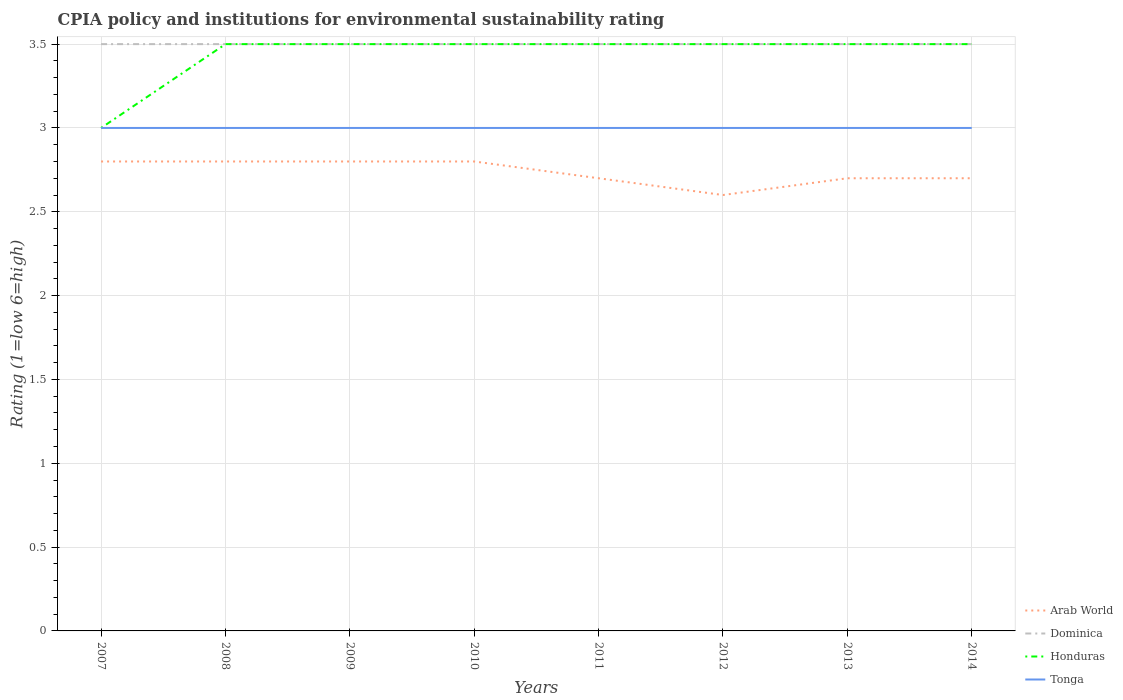How many different coloured lines are there?
Make the answer very short. 4. Does the line corresponding to Dominica intersect with the line corresponding to Tonga?
Keep it short and to the point. No. Is the number of lines equal to the number of legend labels?
Your answer should be very brief. Yes. Across all years, what is the maximum CPIA rating in Arab World?
Ensure brevity in your answer.  2.6. In which year was the CPIA rating in Arab World maximum?
Provide a succinct answer. 2012. What is the total CPIA rating in Arab World in the graph?
Offer a terse response. 0. What is the difference between the highest and the second highest CPIA rating in Tonga?
Offer a terse response. 0. What is the difference between the highest and the lowest CPIA rating in Arab World?
Offer a terse response. 4. How many years are there in the graph?
Ensure brevity in your answer.  8. What is the difference between two consecutive major ticks on the Y-axis?
Your answer should be compact. 0.5. Are the values on the major ticks of Y-axis written in scientific E-notation?
Make the answer very short. No. Does the graph contain any zero values?
Offer a terse response. No. Where does the legend appear in the graph?
Keep it short and to the point. Bottom right. How many legend labels are there?
Ensure brevity in your answer.  4. What is the title of the graph?
Keep it short and to the point. CPIA policy and institutions for environmental sustainability rating. What is the Rating (1=low 6=high) in Honduras in 2007?
Ensure brevity in your answer.  3. What is the Rating (1=low 6=high) of Arab World in 2008?
Offer a very short reply. 2.8. What is the Rating (1=low 6=high) of Dominica in 2008?
Ensure brevity in your answer.  3.5. What is the Rating (1=low 6=high) of Honduras in 2008?
Provide a short and direct response. 3.5. What is the Rating (1=low 6=high) of Dominica in 2009?
Make the answer very short. 3.5. What is the Rating (1=low 6=high) of Honduras in 2009?
Provide a succinct answer. 3.5. What is the Rating (1=low 6=high) of Dominica in 2010?
Provide a succinct answer. 3.5. What is the Rating (1=low 6=high) of Honduras in 2010?
Make the answer very short. 3.5. What is the Rating (1=low 6=high) of Tonga in 2010?
Your answer should be compact. 3. What is the Rating (1=low 6=high) of Tonga in 2011?
Ensure brevity in your answer.  3. What is the Rating (1=low 6=high) in Arab World in 2012?
Your response must be concise. 2.6. What is the Rating (1=low 6=high) in Dominica in 2012?
Your answer should be very brief. 3.5. What is the Rating (1=low 6=high) in Honduras in 2012?
Your answer should be compact. 3.5. What is the Rating (1=low 6=high) in Dominica in 2013?
Offer a terse response. 3.5. What is the Rating (1=low 6=high) in Tonga in 2013?
Offer a very short reply. 3. What is the Rating (1=low 6=high) of Arab World in 2014?
Provide a succinct answer. 2.7. What is the Rating (1=low 6=high) of Dominica in 2014?
Ensure brevity in your answer.  3.5. What is the Rating (1=low 6=high) in Tonga in 2014?
Your answer should be compact. 3. Across all years, what is the maximum Rating (1=low 6=high) of Arab World?
Provide a short and direct response. 2.8. Across all years, what is the maximum Rating (1=low 6=high) in Dominica?
Give a very brief answer. 3.5. Across all years, what is the maximum Rating (1=low 6=high) in Tonga?
Offer a terse response. 3. Across all years, what is the minimum Rating (1=low 6=high) of Arab World?
Make the answer very short. 2.6. Across all years, what is the minimum Rating (1=low 6=high) in Dominica?
Your answer should be very brief. 3.5. Across all years, what is the minimum Rating (1=low 6=high) in Honduras?
Your answer should be compact. 3. Across all years, what is the minimum Rating (1=low 6=high) in Tonga?
Make the answer very short. 3. What is the total Rating (1=low 6=high) of Arab World in the graph?
Give a very brief answer. 21.9. What is the total Rating (1=low 6=high) of Dominica in the graph?
Your answer should be very brief. 28. What is the total Rating (1=low 6=high) in Tonga in the graph?
Give a very brief answer. 24. What is the difference between the Rating (1=low 6=high) in Tonga in 2007 and that in 2009?
Offer a very short reply. 0. What is the difference between the Rating (1=low 6=high) in Honduras in 2007 and that in 2010?
Provide a short and direct response. -0.5. What is the difference between the Rating (1=low 6=high) in Tonga in 2007 and that in 2010?
Provide a succinct answer. 0. What is the difference between the Rating (1=low 6=high) in Arab World in 2007 and that in 2011?
Offer a very short reply. 0.1. What is the difference between the Rating (1=low 6=high) of Dominica in 2007 and that in 2011?
Your answer should be compact. 0. What is the difference between the Rating (1=low 6=high) of Honduras in 2007 and that in 2011?
Provide a short and direct response. -0.5. What is the difference between the Rating (1=low 6=high) of Tonga in 2007 and that in 2011?
Provide a short and direct response. 0. What is the difference between the Rating (1=low 6=high) in Dominica in 2007 and that in 2012?
Keep it short and to the point. 0. What is the difference between the Rating (1=low 6=high) of Honduras in 2007 and that in 2012?
Your response must be concise. -0.5. What is the difference between the Rating (1=low 6=high) of Tonga in 2007 and that in 2012?
Your answer should be very brief. 0. What is the difference between the Rating (1=low 6=high) of Arab World in 2007 and that in 2013?
Offer a very short reply. 0.1. What is the difference between the Rating (1=low 6=high) in Dominica in 2007 and that in 2013?
Ensure brevity in your answer.  0. What is the difference between the Rating (1=low 6=high) in Honduras in 2007 and that in 2014?
Offer a very short reply. -0.5. What is the difference between the Rating (1=low 6=high) in Arab World in 2008 and that in 2009?
Your response must be concise. 0. What is the difference between the Rating (1=low 6=high) of Dominica in 2008 and that in 2009?
Ensure brevity in your answer.  0. What is the difference between the Rating (1=low 6=high) in Arab World in 2008 and that in 2010?
Keep it short and to the point. 0. What is the difference between the Rating (1=low 6=high) in Dominica in 2008 and that in 2010?
Your response must be concise. 0. What is the difference between the Rating (1=low 6=high) of Honduras in 2008 and that in 2011?
Give a very brief answer. 0. What is the difference between the Rating (1=low 6=high) of Dominica in 2008 and that in 2012?
Your response must be concise. 0. What is the difference between the Rating (1=low 6=high) of Arab World in 2008 and that in 2013?
Provide a short and direct response. 0.1. What is the difference between the Rating (1=low 6=high) of Dominica in 2008 and that in 2013?
Your response must be concise. 0. What is the difference between the Rating (1=low 6=high) in Honduras in 2008 and that in 2013?
Offer a very short reply. 0. What is the difference between the Rating (1=low 6=high) of Dominica in 2008 and that in 2014?
Your response must be concise. 0. What is the difference between the Rating (1=low 6=high) of Arab World in 2009 and that in 2011?
Ensure brevity in your answer.  0.1. What is the difference between the Rating (1=low 6=high) in Dominica in 2009 and that in 2011?
Keep it short and to the point. 0. What is the difference between the Rating (1=low 6=high) of Honduras in 2009 and that in 2011?
Make the answer very short. 0. What is the difference between the Rating (1=low 6=high) in Tonga in 2009 and that in 2011?
Your response must be concise. 0. What is the difference between the Rating (1=low 6=high) in Dominica in 2009 and that in 2012?
Provide a succinct answer. 0. What is the difference between the Rating (1=low 6=high) of Arab World in 2009 and that in 2013?
Offer a very short reply. 0.1. What is the difference between the Rating (1=low 6=high) in Dominica in 2009 and that in 2013?
Your response must be concise. 0. What is the difference between the Rating (1=low 6=high) in Honduras in 2009 and that in 2013?
Your answer should be very brief. 0. What is the difference between the Rating (1=low 6=high) of Arab World in 2009 and that in 2014?
Provide a short and direct response. 0.1. What is the difference between the Rating (1=low 6=high) of Tonga in 2009 and that in 2014?
Provide a succinct answer. 0. What is the difference between the Rating (1=low 6=high) in Honduras in 2010 and that in 2011?
Give a very brief answer. 0. What is the difference between the Rating (1=low 6=high) of Tonga in 2010 and that in 2011?
Ensure brevity in your answer.  0. What is the difference between the Rating (1=low 6=high) in Dominica in 2010 and that in 2012?
Your response must be concise. 0. What is the difference between the Rating (1=low 6=high) of Arab World in 2010 and that in 2013?
Provide a succinct answer. 0.1. What is the difference between the Rating (1=low 6=high) in Honduras in 2010 and that in 2013?
Your answer should be very brief. 0. What is the difference between the Rating (1=low 6=high) of Tonga in 2010 and that in 2013?
Offer a terse response. 0. What is the difference between the Rating (1=low 6=high) in Arab World in 2010 and that in 2014?
Provide a succinct answer. 0.1. What is the difference between the Rating (1=low 6=high) of Tonga in 2010 and that in 2014?
Make the answer very short. 0. What is the difference between the Rating (1=low 6=high) of Tonga in 2011 and that in 2013?
Your answer should be compact. 0. What is the difference between the Rating (1=low 6=high) of Dominica in 2011 and that in 2014?
Provide a short and direct response. 0. What is the difference between the Rating (1=low 6=high) in Arab World in 2012 and that in 2013?
Give a very brief answer. -0.1. What is the difference between the Rating (1=low 6=high) of Honduras in 2012 and that in 2013?
Provide a succinct answer. 0. What is the difference between the Rating (1=low 6=high) in Arab World in 2012 and that in 2014?
Offer a very short reply. -0.1. What is the difference between the Rating (1=low 6=high) in Tonga in 2012 and that in 2014?
Keep it short and to the point. 0. What is the difference between the Rating (1=low 6=high) of Arab World in 2013 and that in 2014?
Provide a short and direct response. 0. What is the difference between the Rating (1=low 6=high) of Honduras in 2013 and that in 2014?
Offer a very short reply. 0. What is the difference between the Rating (1=low 6=high) in Arab World in 2007 and the Rating (1=low 6=high) in Dominica in 2008?
Offer a very short reply. -0.7. What is the difference between the Rating (1=low 6=high) of Dominica in 2007 and the Rating (1=low 6=high) of Tonga in 2008?
Give a very brief answer. 0.5. What is the difference between the Rating (1=low 6=high) of Arab World in 2007 and the Rating (1=low 6=high) of Honduras in 2009?
Your answer should be very brief. -0.7. What is the difference between the Rating (1=low 6=high) in Dominica in 2007 and the Rating (1=low 6=high) in Honduras in 2009?
Offer a terse response. 0. What is the difference between the Rating (1=low 6=high) in Honduras in 2007 and the Rating (1=low 6=high) in Tonga in 2009?
Offer a very short reply. 0. What is the difference between the Rating (1=low 6=high) in Arab World in 2007 and the Rating (1=low 6=high) in Dominica in 2010?
Keep it short and to the point. -0.7. What is the difference between the Rating (1=low 6=high) in Arab World in 2007 and the Rating (1=low 6=high) in Tonga in 2010?
Your answer should be compact. -0.2. What is the difference between the Rating (1=low 6=high) in Dominica in 2007 and the Rating (1=low 6=high) in Honduras in 2010?
Provide a succinct answer. 0. What is the difference between the Rating (1=low 6=high) in Dominica in 2007 and the Rating (1=low 6=high) in Tonga in 2010?
Provide a short and direct response. 0.5. What is the difference between the Rating (1=low 6=high) of Arab World in 2007 and the Rating (1=low 6=high) of Dominica in 2011?
Give a very brief answer. -0.7. What is the difference between the Rating (1=low 6=high) of Arab World in 2007 and the Rating (1=low 6=high) of Tonga in 2011?
Make the answer very short. -0.2. What is the difference between the Rating (1=low 6=high) in Dominica in 2007 and the Rating (1=low 6=high) in Tonga in 2011?
Provide a short and direct response. 0.5. What is the difference between the Rating (1=low 6=high) in Honduras in 2007 and the Rating (1=low 6=high) in Tonga in 2011?
Your answer should be very brief. 0. What is the difference between the Rating (1=low 6=high) of Arab World in 2007 and the Rating (1=low 6=high) of Honduras in 2012?
Your answer should be compact. -0.7. What is the difference between the Rating (1=low 6=high) of Arab World in 2007 and the Rating (1=low 6=high) of Tonga in 2012?
Offer a very short reply. -0.2. What is the difference between the Rating (1=low 6=high) in Arab World in 2007 and the Rating (1=low 6=high) in Dominica in 2013?
Offer a very short reply. -0.7. What is the difference between the Rating (1=low 6=high) in Dominica in 2007 and the Rating (1=low 6=high) in Honduras in 2013?
Your answer should be very brief. 0. What is the difference between the Rating (1=low 6=high) of Dominica in 2007 and the Rating (1=low 6=high) of Tonga in 2013?
Make the answer very short. 0.5. What is the difference between the Rating (1=low 6=high) in Arab World in 2007 and the Rating (1=low 6=high) in Dominica in 2014?
Your response must be concise. -0.7. What is the difference between the Rating (1=low 6=high) in Arab World in 2007 and the Rating (1=low 6=high) in Tonga in 2014?
Offer a terse response. -0.2. What is the difference between the Rating (1=low 6=high) in Dominica in 2007 and the Rating (1=low 6=high) in Honduras in 2014?
Offer a very short reply. 0. What is the difference between the Rating (1=low 6=high) of Dominica in 2007 and the Rating (1=low 6=high) of Tonga in 2014?
Offer a very short reply. 0.5. What is the difference between the Rating (1=low 6=high) of Arab World in 2008 and the Rating (1=low 6=high) of Dominica in 2009?
Provide a succinct answer. -0.7. What is the difference between the Rating (1=low 6=high) of Arab World in 2008 and the Rating (1=low 6=high) of Tonga in 2009?
Offer a very short reply. -0.2. What is the difference between the Rating (1=low 6=high) of Dominica in 2008 and the Rating (1=low 6=high) of Tonga in 2009?
Your answer should be compact. 0.5. What is the difference between the Rating (1=low 6=high) in Arab World in 2008 and the Rating (1=low 6=high) in Dominica in 2010?
Give a very brief answer. -0.7. What is the difference between the Rating (1=low 6=high) of Arab World in 2008 and the Rating (1=low 6=high) of Honduras in 2010?
Offer a terse response. -0.7. What is the difference between the Rating (1=low 6=high) of Arab World in 2008 and the Rating (1=low 6=high) of Tonga in 2010?
Offer a terse response. -0.2. What is the difference between the Rating (1=low 6=high) of Dominica in 2008 and the Rating (1=low 6=high) of Tonga in 2010?
Offer a terse response. 0.5. What is the difference between the Rating (1=low 6=high) in Honduras in 2008 and the Rating (1=low 6=high) in Tonga in 2010?
Your answer should be very brief. 0.5. What is the difference between the Rating (1=low 6=high) in Arab World in 2008 and the Rating (1=low 6=high) in Honduras in 2011?
Your answer should be compact. -0.7. What is the difference between the Rating (1=low 6=high) of Arab World in 2008 and the Rating (1=low 6=high) of Tonga in 2011?
Offer a terse response. -0.2. What is the difference between the Rating (1=low 6=high) in Dominica in 2008 and the Rating (1=low 6=high) in Honduras in 2011?
Your response must be concise. 0. What is the difference between the Rating (1=low 6=high) in Honduras in 2008 and the Rating (1=low 6=high) in Tonga in 2011?
Provide a succinct answer. 0.5. What is the difference between the Rating (1=low 6=high) in Arab World in 2008 and the Rating (1=low 6=high) in Honduras in 2012?
Offer a terse response. -0.7. What is the difference between the Rating (1=low 6=high) of Arab World in 2008 and the Rating (1=low 6=high) of Tonga in 2012?
Your answer should be very brief. -0.2. What is the difference between the Rating (1=low 6=high) of Honduras in 2008 and the Rating (1=low 6=high) of Tonga in 2012?
Your response must be concise. 0.5. What is the difference between the Rating (1=low 6=high) in Arab World in 2008 and the Rating (1=low 6=high) in Honduras in 2013?
Ensure brevity in your answer.  -0.7. What is the difference between the Rating (1=low 6=high) of Honduras in 2008 and the Rating (1=low 6=high) of Tonga in 2013?
Make the answer very short. 0.5. What is the difference between the Rating (1=low 6=high) of Arab World in 2008 and the Rating (1=low 6=high) of Dominica in 2014?
Keep it short and to the point. -0.7. What is the difference between the Rating (1=low 6=high) of Arab World in 2008 and the Rating (1=low 6=high) of Honduras in 2014?
Give a very brief answer. -0.7. What is the difference between the Rating (1=low 6=high) of Arab World in 2008 and the Rating (1=low 6=high) of Tonga in 2014?
Offer a terse response. -0.2. What is the difference between the Rating (1=low 6=high) in Dominica in 2008 and the Rating (1=low 6=high) in Tonga in 2014?
Offer a very short reply. 0.5. What is the difference between the Rating (1=low 6=high) of Honduras in 2008 and the Rating (1=low 6=high) of Tonga in 2014?
Give a very brief answer. 0.5. What is the difference between the Rating (1=low 6=high) in Arab World in 2009 and the Rating (1=low 6=high) in Honduras in 2010?
Offer a very short reply. -0.7. What is the difference between the Rating (1=low 6=high) in Arab World in 2009 and the Rating (1=low 6=high) in Tonga in 2010?
Offer a terse response. -0.2. What is the difference between the Rating (1=low 6=high) of Dominica in 2009 and the Rating (1=low 6=high) of Honduras in 2010?
Your answer should be compact. 0. What is the difference between the Rating (1=low 6=high) of Honduras in 2009 and the Rating (1=low 6=high) of Tonga in 2010?
Make the answer very short. 0.5. What is the difference between the Rating (1=low 6=high) of Arab World in 2009 and the Rating (1=low 6=high) of Honduras in 2011?
Provide a short and direct response. -0.7. What is the difference between the Rating (1=low 6=high) of Arab World in 2009 and the Rating (1=low 6=high) of Tonga in 2011?
Your response must be concise. -0.2. What is the difference between the Rating (1=low 6=high) of Honduras in 2009 and the Rating (1=low 6=high) of Tonga in 2011?
Keep it short and to the point. 0.5. What is the difference between the Rating (1=low 6=high) in Arab World in 2009 and the Rating (1=low 6=high) in Honduras in 2012?
Your response must be concise. -0.7. What is the difference between the Rating (1=low 6=high) in Dominica in 2009 and the Rating (1=low 6=high) in Tonga in 2012?
Make the answer very short. 0.5. What is the difference between the Rating (1=low 6=high) of Honduras in 2009 and the Rating (1=low 6=high) of Tonga in 2012?
Your response must be concise. 0.5. What is the difference between the Rating (1=low 6=high) in Arab World in 2009 and the Rating (1=low 6=high) in Dominica in 2013?
Give a very brief answer. -0.7. What is the difference between the Rating (1=low 6=high) of Dominica in 2009 and the Rating (1=low 6=high) of Honduras in 2013?
Ensure brevity in your answer.  0. What is the difference between the Rating (1=low 6=high) of Arab World in 2009 and the Rating (1=low 6=high) of Dominica in 2014?
Provide a succinct answer. -0.7. What is the difference between the Rating (1=low 6=high) of Arab World in 2010 and the Rating (1=low 6=high) of Dominica in 2011?
Your response must be concise. -0.7. What is the difference between the Rating (1=low 6=high) of Dominica in 2010 and the Rating (1=low 6=high) of Honduras in 2011?
Keep it short and to the point. 0. What is the difference between the Rating (1=low 6=high) of Arab World in 2010 and the Rating (1=low 6=high) of Dominica in 2012?
Your answer should be compact. -0.7. What is the difference between the Rating (1=low 6=high) in Arab World in 2010 and the Rating (1=low 6=high) in Tonga in 2012?
Ensure brevity in your answer.  -0.2. What is the difference between the Rating (1=low 6=high) of Dominica in 2010 and the Rating (1=low 6=high) of Tonga in 2012?
Your response must be concise. 0.5. What is the difference between the Rating (1=low 6=high) of Honduras in 2010 and the Rating (1=low 6=high) of Tonga in 2012?
Provide a short and direct response. 0.5. What is the difference between the Rating (1=low 6=high) of Arab World in 2010 and the Rating (1=low 6=high) of Honduras in 2013?
Provide a succinct answer. -0.7. What is the difference between the Rating (1=low 6=high) of Honduras in 2010 and the Rating (1=low 6=high) of Tonga in 2013?
Your response must be concise. 0.5. What is the difference between the Rating (1=low 6=high) in Arab World in 2010 and the Rating (1=low 6=high) in Dominica in 2014?
Your answer should be very brief. -0.7. What is the difference between the Rating (1=low 6=high) in Dominica in 2010 and the Rating (1=low 6=high) in Tonga in 2014?
Your answer should be compact. 0.5. What is the difference between the Rating (1=low 6=high) of Honduras in 2010 and the Rating (1=low 6=high) of Tonga in 2014?
Provide a succinct answer. 0.5. What is the difference between the Rating (1=low 6=high) of Arab World in 2011 and the Rating (1=low 6=high) of Dominica in 2012?
Your answer should be very brief. -0.8. What is the difference between the Rating (1=low 6=high) in Arab World in 2011 and the Rating (1=low 6=high) in Tonga in 2012?
Offer a terse response. -0.3. What is the difference between the Rating (1=low 6=high) of Dominica in 2011 and the Rating (1=low 6=high) of Honduras in 2012?
Ensure brevity in your answer.  0. What is the difference between the Rating (1=low 6=high) of Dominica in 2011 and the Rating (1=low 6=high) of Tonga in 2012?
Your answer should be very brief. 0.5. What is the difference between the Rating (1=low 6=high) in Arab World in 2011 and the Rating (1=low 6=high) in Dominica in 2013?
Make the answer very short. -0.8. What is the difference between the Rating (1=low 6=high) in Arab World in 2011 and the Rating (1=low 6=high) in Honduras in 2013?
Offer a terse response. -0.8. What is the difference between the Rating (1=low 6=high) of Arab World in 2011 and the Rating (1=low 6=high) of Tonga in 2013?
Keep it short and to the point. -0.3. What is the difference between the Rating (1=low 6=high) in Dominica in 2011 and the Rating (1=low 6=high) in Honduras in 2013?
Your response must be concise. 0. What is the difference between the Rating (1=low 6=high) in Honduras in 2011 and the Rating (1=low 6=high) in Tonga in 2013?
Give a very brief answer. 0.5. What is the difference between the Rating (1=low 6=high) of Arab World in 2011 and the Rating (1=low 6=high) of Dominica in 2014?
Provide a short and direct response. -0.8. What is the difference between the Rating (1=low 6=high) of Arab World in 2011 and the Rating (1=low 6=high) of Tonga in 2014?
Provide a succinct answer. -0.3. What is the difference between the Rating (1=low 6=high) in Dominica in 2011 and the Rating (1=low 6=high) in Honduras in 2014?
Provide a short and direct response. 0. What is the difference between the Rating (1=low 6=high) in Dominica in 2011 and the Rating (1=low 6=high) in Tonga in 2014?
Your answer should be very brief. 0.5. What is the difference between the Rating (1=low 6=high) of Arab World in 2012 and the Rating (1=low 6=high) of Dominica in 2013?
Provide a short and direct response. -0.9. What is the difference between the Rating (1=low 6=high) in Arab World in 2012 and the Rating (1=low 6=high) in Honduras in 2013?
Provide a succinct answer. -0.9. What is the difference between the Rating (1=low 6=high) of Arab World in 2012 and the Rating (1=low 6=high) of Tonga in 2013?
Keep it short and to the point. -0.4. What is the difference between the Rating (1=low 6=high) of Dominica in 2012 and the Rating (1=low 6=high) of Tonga in 2013?
Provide a short and direct response. 0.5. What is the difference between the Rating (1=low 6=high) in Honduras in 2012 and the Rating (1=low 6=high) in Tonga in 2013?
Provide a succinct answer. 0.5. What is the difference between the Rating (1=low 6=high) of Arab World in 2012 and the Rating (1=low 6=high) of Dominica in 2014?
Keep it short and to the point. -0.9. What is the difference between the Rating (1=low 6=high) in Arab World in 2012 and the Rating (1=low 6=high) in Honduras in 2014?
Give a very brief answer. -0.9. What is the difference between the Rating (1=low 6=high) in Dominica in 2012 and the Rating (1=low 6=high) in Honduras in 2014?
Offer a very short reply. 0. What is the difference between the Rating (1=low 6=high) in Arab World in 2013 and the Rating (1=low 6=high) in Honduras in 2014?
Make the answer very short. -0.8. What is the difference between the Rating (1=low 6=high) in Arab World in 2013 and the Rating (1=low 6=high) in Tonga in 2014?
Offer a very short reply. -0.3. What is the difference between the Rating (1=low 6=high) in Dominica in 2013 and the Rating (1=low 6=high) in Tonga in 2014?
Keep it short and to the point. 0.5. What is the difference between the Rating (1=low 6=high) in Honduras in 2013 and the Rating (1=low 6=high) in Tonga in 2014?
Your response must be concise. 0.5. What is the average Rating (1=low 6=high) of Arab World per year?
Your answer should be compact. 2.74. What is the average Rating (1=low 6=high) of Dominica per year?
Ensure brevity in your answer.  3.5. What is the average Rating (1=low 6=high) of Honduras per year?
Your answer should be compact. 3.44. What is the average Rating (1=low 6=high) in Tonga per year?
Your answer should be compact. 3. In the year 2007, what is the difference between the Rating (1=low 6=high) in Arab World and Rating (1=low 6=high) in Honduras?
Ensure brevity in your answer.  -0.2. In the year 2007, what is the difference between the Rating (1=low 6=high) of Arab World and Rating (1=low 6=high) of Tonga?
Your response must be concise. -0.2. In the year 2007, what is the difference between the Rating (1=low 6=high) of Dominica and Rating (1=low 6=high) of Tonga?
Give a very brief answer. 0.5. In the year 2008, what is the difference between the Rating (1=low 6=high) of Arab World and Rating (1=low 6=high) of Honduras?
Your response must be concise. -0.7. In the year 2008, what is the difference between the Rating (1=low 6=high) of Arab World and Rating (1=low 6=high) of Tonga?
Offer a terse response. -0.2. In the year 2008, what is the difference between the Rating (1=low 6=high) in Dominica and Rating (1=low 6=high) in Honduras?
Provide a short and direct response. 0. In the year 2009, what is the difference between the Rating (1=low 6=high) in Arab World and Rating (1=low 6=high) in Dominica?
Your answer should be compact. -0.7. In the year 2009, what is the difference between the Rating (1=low 6=high) in Arab World and Rating (1=low 6=high) in Honduras?
Make the answer very short. -0.7. In the year 2009, what is the difference between the Rating (1=low 6=high) in Dominica and Rating (1=low 6=high) in Honduras?
Provide a succinct answer. 0. In the year 2009, what is the difference between the Rating (1=low 6=high) of Dominica and Rating (1=low 6=high) of Tonga?
Your response must be concise. 0.5. In the year 2009, what is the difference between the Rating (1=low 6=high) in Honduras and Rating (1=low 6=high) in Tonga?
Your answer should be compact. 0.5. In the year 2010, what is the difference between the Rating (1=low 6=high) of Arab World and Rating (1=low 6=high) of Dominica?
Offer a very short reply. -0.7. In the year 2010, what is the difference between the Rating (1=low 6=high) in Arab World and Rating (1=low 6=high) in Honduras?
Offer a very short reply. -0.7. In the year 2010, what is the difference between the Rating (1=low 6=high) in Arab World and Rating (1=low 6=high) in Tonga?
Make the answer very short. -0.2. In the year 2010, what is the difference between the Rating (1=low 6=high) of Dominica and Rating (1=low 6=high) of Honduras?
Offer a very short reply. 0. In the year 2011, what is the difference between the Rating (1=low 6=high) in Dominica and Rating (1=low 6=high) in Honduras?
Make the answer very short. 0. In the year 2012, what is the difference between the Rating (1=low 6=high) of Arab World and Rating (1=low 6=high) of Tonga?
Your answer should be compact. -0.4. In the year 2012, what is the difference between the Rating (1=low 6=high) of Dominica and Rating (1=low 6=high) of Tonga?
Keep it short and to the point. 0.5. In the year 2013, what is the difference between the Rating (1=low 6=high) in Arab World and Rating (1=low 6=high) in Honduras?
Keep it short and to the point. -0.8. In the year 2013, what is the difference between the Rating (1=low 6=high) of Dominica and Rating (1=low 6=high) of Honduras?
Your answer should be very brief. 0. In the year 2013, what is the difference between the Rating (1=low 6=high) of Dominica and Rating (1=low 6=high) of Tonga?
Your answer should be very brief. 0.5. In the year 2014, what is the difference between the Rating (1=low 6=high) in Dominica and Rating (1=low 6=high) in Honduras?
Your response must be concise. 0. What is the ratio of the Rating (1=low 6=high) in Dominica in 2007 to that in 2008?
Ensure brevity in your answer.  1. What is the ratio of the Rating (1=low 6=high) of Honduras in 2007 to that in 2008?
Offer a terse response. 0.86. What is the ratio of the Rating (1=low 6=high) of Tonga in 2007 to that in 2008?
Give a very brief answer. 1. What is the ratio of the Rating (1=low 6=high) of Arab World in 2007 to that in 2009?
Make the answer very short. 1. What is the ratio of the Rating (1=low 6=high) in Dominica in 2007 to that in 2009?
Provide a succinct answer. 1. What is the ratio of the Rating (1=low 6=high) in Arab World in 2007 to that in 2010?
Give a very brief answer. 1. What is the ratio of the Rating (1=low 6=high) of Dominica in 2007 to that in 2010?
Your answer should be very brief. 1. What is the ratio of the Rating (1=low 6=high) of Tonga in 2007 to that in 2010?
Provide a succinct answer. 1. What is the ratio of the Rating (1=low 6=high) of Arab World in 2007 to that in 2011?
Offer a terse response. 1.04. What is the ratio of the Rating (1=low 6=high) in Dominica in 2007 to that in 2011?
Ensure brevity in your answer.  1. What is the ratio of the Rating (1=low 6=high) in Dominica in 2007 to that in 2012?
Your answer should be compact. 1. What is the ratio of the Rating (1=low 6=high) in Tonga in 2007 to that in 2012?
Offer a very short reply. 1. What is the ratio of the Rating (1=low 6=high) of Arab World in 2007 to that in 2013?
Provide a short and direct response. 1.04. What is the ratio of the Rating (1=low 6=high) in Dominica in 2007 to that in 2013?
Your answer should be very brief. 1. What is the ratio of the Rating (1=low 6=high) in Honduras in 2007 to that in 2013?
Offer a terse response. 0.86. What is the ratio of the Rating (1=low 6=high) in Dominica in 2007 to that in 2014?
Provide a succinct answer. 1. What is the ratio of the Rating (1=low 6=high) of Honduras in 2007 to that in 2014?
Offer a very short reply. 0.86. What is the ratio of the Rating (1=low 6=high) of Arab World in 2008 to that in 2009?
Give a very brief answer. 1. What is the ratio of the Rating (1=low 6=high) of Dominica in 2008 to that in 2010?
Make the answer very short. 1. What is the ratio of the Rating (1=low 6=high) of Honduras in 2008 to that in 2010?
Make the answer very short. 1. What is the ratio of the Rating (1=low 6=high) of Tonga in 2008 to that in 2010?
Make the answer very short. 1. What is the ratio of the Rating (1=low 6=high) in Honduras in 2008 to that in 2011?
Offer a terse response. 1. What is the ratio of the Rating (1=low 6=high) of Arab World in 2008 to that in 2012?
Offer a very short reply. 1.08. What is the ratio of the Rating (1=low 6=high) of Honduras in 2008 to that in 2012?
Keep it short and to the point. 1. What is the ratio of the Rating (1=low 6=high) in Tonga in 2008 to that in 2012?
Provide a succinct answer. 1. What is the ratio of the Rating (1=low 6=high) in Tonga in 2008 to that in 2013?
Your response must be concise. 1. What is the ratio of the Rating (1=low 6=high) in Arab World in 2008 to that in 2014?
Your answer should be very brief. 1.04. What is the ratio of the Rating (1=low 6=high) in Honduras in 2008 to that in 2014?
Offer a terse response. 1. What is the ratio of the Rating (1=low 6=high) of Dominica in 2009 to that in 2010?
Provide a succinct answer. 1. What is the ratio of the Rating (1=low 6=high) of Honduras in 2009 to that in 2010?
Provide a succinct answer. 1. What is the ratio of the Rating (1=low 6=high) of Tonga in 2009 to that in 2010?
Offer a terse response. 1. What is the ratio of the Rating (1=low 6=high) in Dominica in 2009 to that in 2011?
Provide a short and direct response. 1. What is the ratio of the Rating (1=low 6=high) in Arab World in 2009 to that in 2012?
Offer a very short reply. 1.08. What is the ratio of the Rating (1=low 6=high) in Honduras in 2009 to that in 2012?
Provide a succinct answer. 1. What is the ratio of the Rating (1=low 6=high) in Arab World in 2009 to that in 2013?
Offer a terse response. 1.04. What is the ratio of the Rating (1=low 6=high) of Dominica in 2009 to that in 2013?
Make the answer very short. 1. What is the ratio of the Rating (1=low 6=high) in Arab World in 2009 to that in 2014?
Offer a very short reply. 1.04. What is the ratio of the Rating (1=low 6=high) in Honduras in 2009 to that in 2014?
Your response must be concise. 1. What is the ratio of the Rating (1=low 6=high) of Arab World in 2010 to that in 2011?
Make the answer very short. 1.04. What is the ratio of the Rating (1=low 6=high) in Dominica in 2010 to that in 2011?
Make the answer very short. 1. What is the ratio of the Rating (1=low 6=high) of Honduras in 2010 to that in 2012?
Your response must be concise. 1. What is the ratio of the Rating (1=low 6=high) in Tonga in 2010 to that in 2012?
Offer a very short reply. 1. What is the ratio of the Rating (1=low 6=high) of Arab World in 2010 to that in 2013?
Your answer should be very brief. 1.04. What is the ratio of the Rating (1=low 6=high) of Tonga in 2010 to that in 2014?
Provide a short and direct response. 1. What is the ratio of the Rating (1=low 6=high) in Tonga in 2011 to that in 2012?
Provide a succinct answer. 1. What is the ratio of the Rating (1=low 6=high) in Arab World in 2011 to that in 2013?
Provide a short and direct response. 1. What is the ratio of the Rating (1=low 6=high) in Dominica in 2011 to that in 2013?
Make the answer very short. 1. What is the ratio of the Rating (1=low 6=high) of Honduras in 2011 to that in 2013?
Make the answer very short. 1. What is the ratio of the Rating (1=low 6=high) in Arab World in 2011 to that in 2014?
Your answer should be very brief. 1. What is the ratio of the Rating (1=low 6=high) of Dominica in 2011 to that in 2014?
Ensure brevity in your answer.  1. What is the ratio of the Rating (1=low 6=high) in Tonga in 2011 to that in 2014?
Offer a terse response. 1. What is the ratio of the Rating (1=low 6=high) of Dominica in 2012 to that in 2013?
Provide a succinct answer. 1. What is the ratio of the Rating (1=low 6=high) in Honduras in 2012 to that in 2013?
Provide a short and direct response. 1. What is the ratio of the Rating (1=low 6=high) of Tonga in 2012 to that in 2013?
Provide a succinct answer. 1. What is the ratio of the Rating (1=low 6=high) in Dominica in 2012 to that in 2014?
Make the answer very short. 1. What is the ratio of the Rating (1=low 6=high) of Honduras in 2012 to that in 2014?
Make the answer very short. 1. What is the ratio of the Rating (1=low 6=high) in Tonga in 2012 to that in 2014?
Your answer should be very brief. 1. What is the ratio of the Rating (1=low 6=high) in Arab World in 2013 to that in 2014?
Make the answer very short. 1. What is the ratio of the Rating (1=low 6=high) in Tonga in 2013 to that in 2014?
Your answer should be very brief. 1. What is the difference between the highest and the second highest Rating (1=low 6=high) in Dominica?
Keep it short and to the point. 0. 